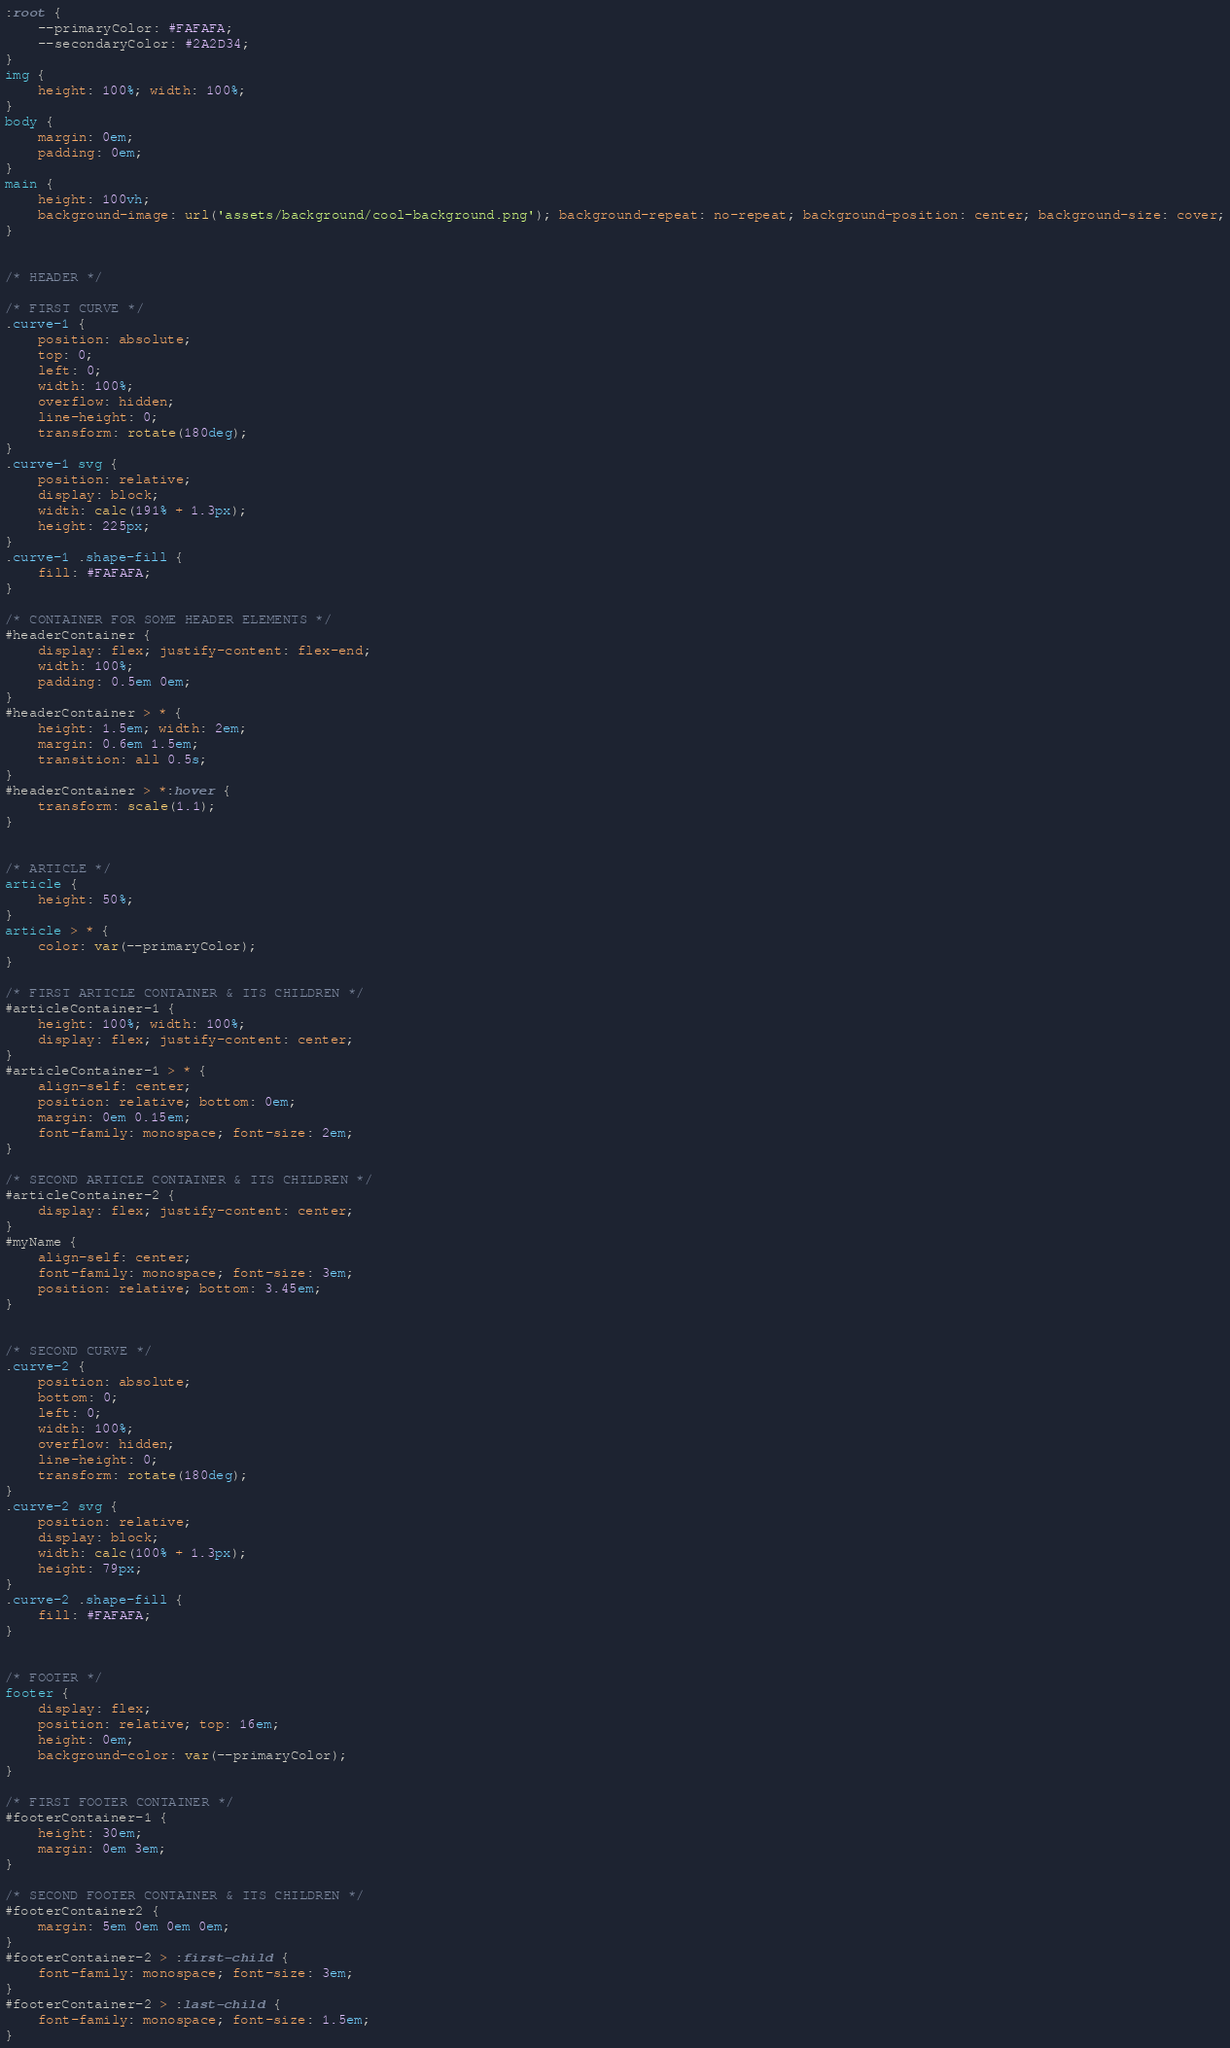<code> <loc_0><loc_0><loc_500><loc_500><_CSS_>:root {
    --primaryColor: #FAFAFA;
    --secondaryColor: #2A2D34;
}
img {
    height: 100%; width: 100%;
}
body {
    margin: 0em;
    padding: 0em;
}
main {
    height: 100vh;
    background-image: url('assets/background/cool-background.png'); background-repeat: no-repeat; background-position: center; background-size: cover;
}


/* HEADER */

/* FIRST CURVE */
.curve-1 {
    position: absolute;
    top: 0;
    left: 0;
    width: 100%;
    overflow: hidden;
    line-height: 0;
    transform: rotate(180deg);
}
.curve-1 svg {
    position: relative;
    display: block;
    width: calc(191% + 1.3px);
    height: 225px;
}
.curve-1 .shape-fill {
    fill: #FAFAFA;
}

/* CONTAINER FOR SOME HEADER ELEMENTS */
#headerContainer {
    display: flex; justify-content: flex-end;
    width: 100%;
    padding: 0.5em 0em;
}
#headerContainer > * {
    height: 1.5em; width: 2em;
    margin: 0.6em 1.5em;
    transition: all 0.5s;
}
#headerContainer > *:hover {
    transform: scale(1.1);
}


/* ARTICLE */
article {
    height: 50%;
}
article > * {
    color: var(--primaryColor);
}

/* FIRST ARTICLE CONTAINER & ITS CHILDREN */
#articleContainer-1 {
    height: 100%; width: 100%;
    display: flex; justify-content: center;
}
#articleContainer-1 > * {
    align-self: center;
    position: relative; bottom: 0em;
    margin: 0em 0.15em;
    font-family: monospace; font-size: 2em;
}

/* SECOND ARTICLE CONTAINER & ITS CHILDREN */
#articleContainer-2 {
    display: flex; justify-content: center;
}
#myName {
    align-self: center;
    font-family: monospace; font-size: 3em;
    position: relative; bottom: 3.45em;
}


/* SECOND CURVE */
.curve-2 {
    position: absolute;
    bottom: 0;
    left: 0;
    width: 100%;
    overflow: hidden;
    line-height: 0;
    transform: rotate(180deg);
}
.curve-2 svg {
    position: relative;
    display: block;
    width: calc(100% + 1.3px);
    height: 79px;
}
.curve-2 .shape-fill {
    fill: #FAFAFA;
}


/* FOOTER */
footer {
    display: flex;
    position: relative; top: 16em;
    height: 0em;
    background-color: var(--primaryColor);
}

/* FIRST FOOTER CONTAINER */
#footerContainer-1 {
    height: 30em;
    margin: 0em 3em;
}

/* SECOND FOOTER CONTAINER & ITS CHILDREN */
#footerContainer2 {
    margin: 5em 0em 0em 0em;
}
#footerContainer-2 > :first-child {
    font-family: monospace; font-size: 3em;
}
#footerContainer-2 > :last-child {
    font-family: monospace; font-size: 1.5em;
}</code> 